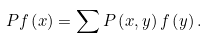<formula> <loc_0><loc_0><loc_500><loc_500>P f \left ( x \right ) = \sum P \left ( x , y \right ) f \left ( y \right ) .</formula> 